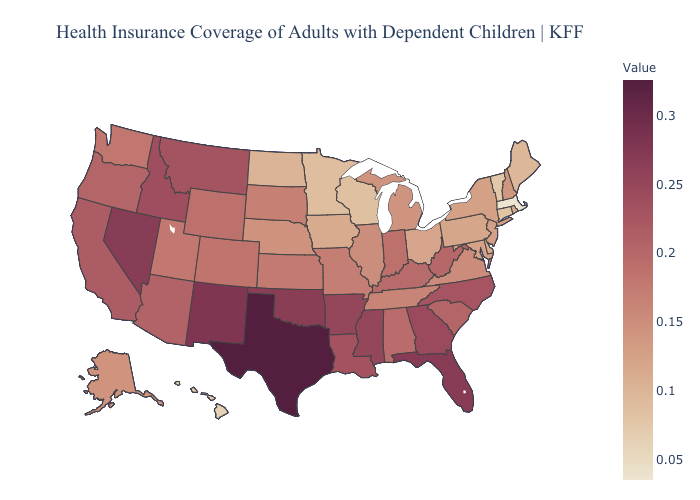Which states have the highest value in the USA?
Quick response, please. Texas. Does Montana have the highest value in the USA?
Be succinct. No. Among the states that border West Virginia , does Pennsylvania have the lowest value?
Be succinct. Yes. 